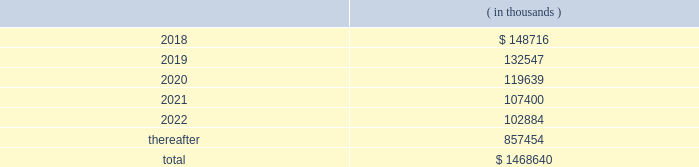Hollyfrontier corporation notes to consolidated financial statements continued .
Transportation and storage costs incurred under these agreements totaled $ 140.5 million , $ 135.1 million and $ 137.7 million for the years ended december 31 , 2017 , 2016 and 2015 , respectively .
These amounts do not include contractual commitments under our long-term transportation agreements with hep , as all transactions with hep are eliminated in these consolidated financial statements .
We have a crude oil supply contract that requires the supplier to deliver a specified volume of crude oil or pay a shortfall fee for the difference in the actual barrels delivered to us less the specified barrels per the supply contract .
For the contract year ended august 31 , 2017 , the actual number of barrels delivered to us was substantially less than the specified barrels , and we recorded a reduction to cost of goods sold and accumulated a shortfall fee receivable of $ 26.0 million during this period .
In september 2017 , the supplier notified us they are disputing the shortfall fee owed and in october 2017 notified us of their demand for arbitration .
We offset the receivable with payments of invoices for deliveries of crude oil received subsequent to august 31 , 2017 , which is permitted under the supply contract .
We believe the disputes and claims made by the supplier are without merit .
In march , 2006 , a subsidiary of ours sold the assets of montana refining company under an asset purchase agreement ( 201capa 201d ) .
Calumet montana refining llc , the current owner of the assets , has submitted requests for reimbursement of approximately $ 20.0 million pursuant to contractual indemnity provisions under the apa for various costs incurred , as well as additional claims related to environmental matters .
We have rejected most of the claims for payment , and this matter is scheduled for arbitration beginning in july 2018 .
We have accrued the costs we believe are owed pursuant to the apa , and we estimate that any reasonably possible losses beyond the amounts accrued are not material .
Note 20 : segment information effective fourth quarter of 2017 , we revised our reportable segments to align with certain changes in how our chief operating decision maker manages and allocates resources to our business .
Accordingly , our tulsa refineries 2019 lubricants operations , previously reported in the refining segment , are now combined with the operations of our petro-canada lubricants business ( acquired february 1 , 2017 ) and reported in the lubricants and specialty products segment .
Our prior period segment information has been retrospectively adjusted to reflect our current segment presentation .
Our operations are organized into three reportable segments , refining , lubricants and specialty products and hep .
Our operations that are not included in the refining , lubricants and specialty products and hep segments are included in corporate and other .
Intersegment transactions are eliminated in our consolidated financial statements and are included in eliminations .
Corporate and other and eliminations are aggregated and presented under corporate , other and eliminations column .
The refining segment represents the operations of the el dorado , tulsa , navajo , cheyenne and woods cross refineries and hfc asphalt ( aggregated as a reportable segment ) .
Refining activities involve the purchase and refining of crude oil and wholesale and branded marketing of refined products , such as gasoline , diesel fuel and jet fuel .
These petroleum products are primarily marketed in the mid-continent , southwest and rocky mountain regions of the united states .
Hfc asphalt operates various asphalt terminals in arizona , new mexico and oklahoma. .
What percentage of total costs occurred after 2022? 
Computations: (857454 / 1468640)
Answer: 0.58384. 